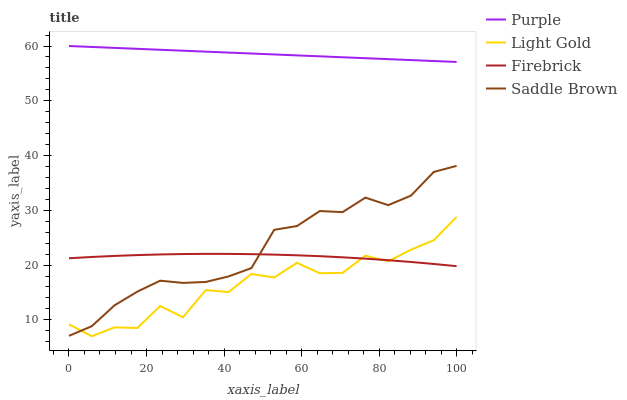Does Light Gold have the minimum area under the curve?
Answer yes or no. Yes. Does Purple have the maximum area under the curve?
Answer yes or no. Yes. Does Firebrick have the minimum area under the curve?
Answer yes or no. No. Does Firebrick have the maximum area under the curve?
Answer yes or no. No. Is Purple the smoothest?
Answer yes or no. Yes. Is Light Gold the roughest?
Answer yes or no. Yes. Is Firebrick the smoothest?
Answer yes or no. No. Is Firebrick the roughest?
Answer yes or no. No. Does Light Gold have the lowest value?
Answer yes or no. Yes. Does Firebrick have the lowest value?
Answer yes or no. No. Does Purple have the highest value?
Answer yes or no. Yes. Does Light Gold have the highest value?
Answer yes or no. No. Is Saddle Brown less than Purple?
Answer yes or no. Yes. Is Purple greater than Saddle Brown?
Answer yes or no. Yes. Does Saddle Brown intersect Light Gold?
Answer yes or no. Yes. Is Saddle Brown less than Light Gold?
Answer yes or no. No. Is Saddle Brown greater than Light Gold?
Answer yes or no. No. Does Saddle Brown intersect Purple?
Answer yes or no. No. 